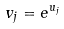<formula> <loc_0><loc_0><loc_500><loc_500>v _ { j } = e ^ { u _ { j } }</formula> 